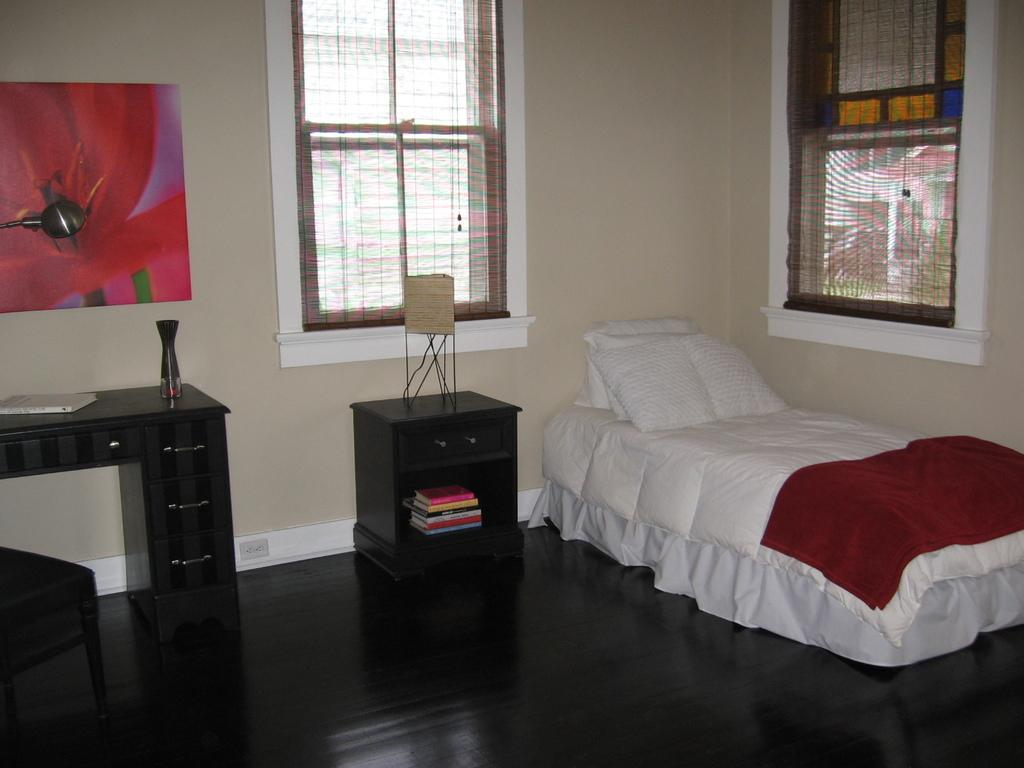What type of room is depicted in the image? The image is of a bedroom. What furniture is present in the bedroom? There is a cupboard, a bed, a chair, and a frame attached to the wall in the room. What items can be found on the bed? A blanket and pillows are present on the bed. What is the purpose of the lamp in the room? The lamp is likely used for providing light in the bedroom. Can you describe the window in the room? There is a window in the room, but its specific features are not mentioned in the facts. How does the beginner learn to use the brain in the image? There is no mention of a beginner or learning in the image, and the image does not depict any brain-related activities. 